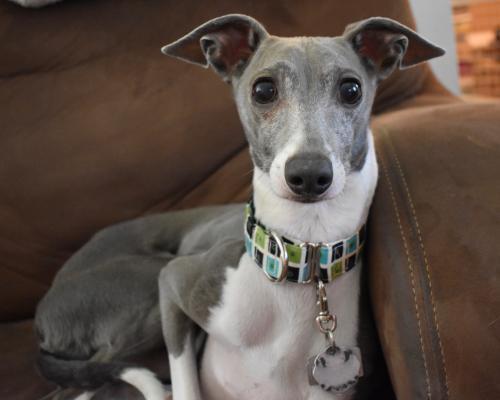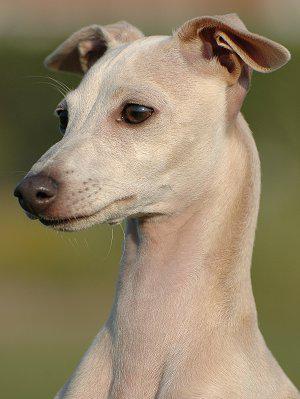The first image is the image on the left, the second image is the image on the right. Considering the images on both sides, is "One of the dogs is resting on a couch." valid? Answer yes or no. Yes. The first image is the image on the left, the second image is the image on the right. For the images displayed, is the sentence "One image shows a mostly light brown dog standing on all fours in the grass." factually correct? Answer yes or no. No. 